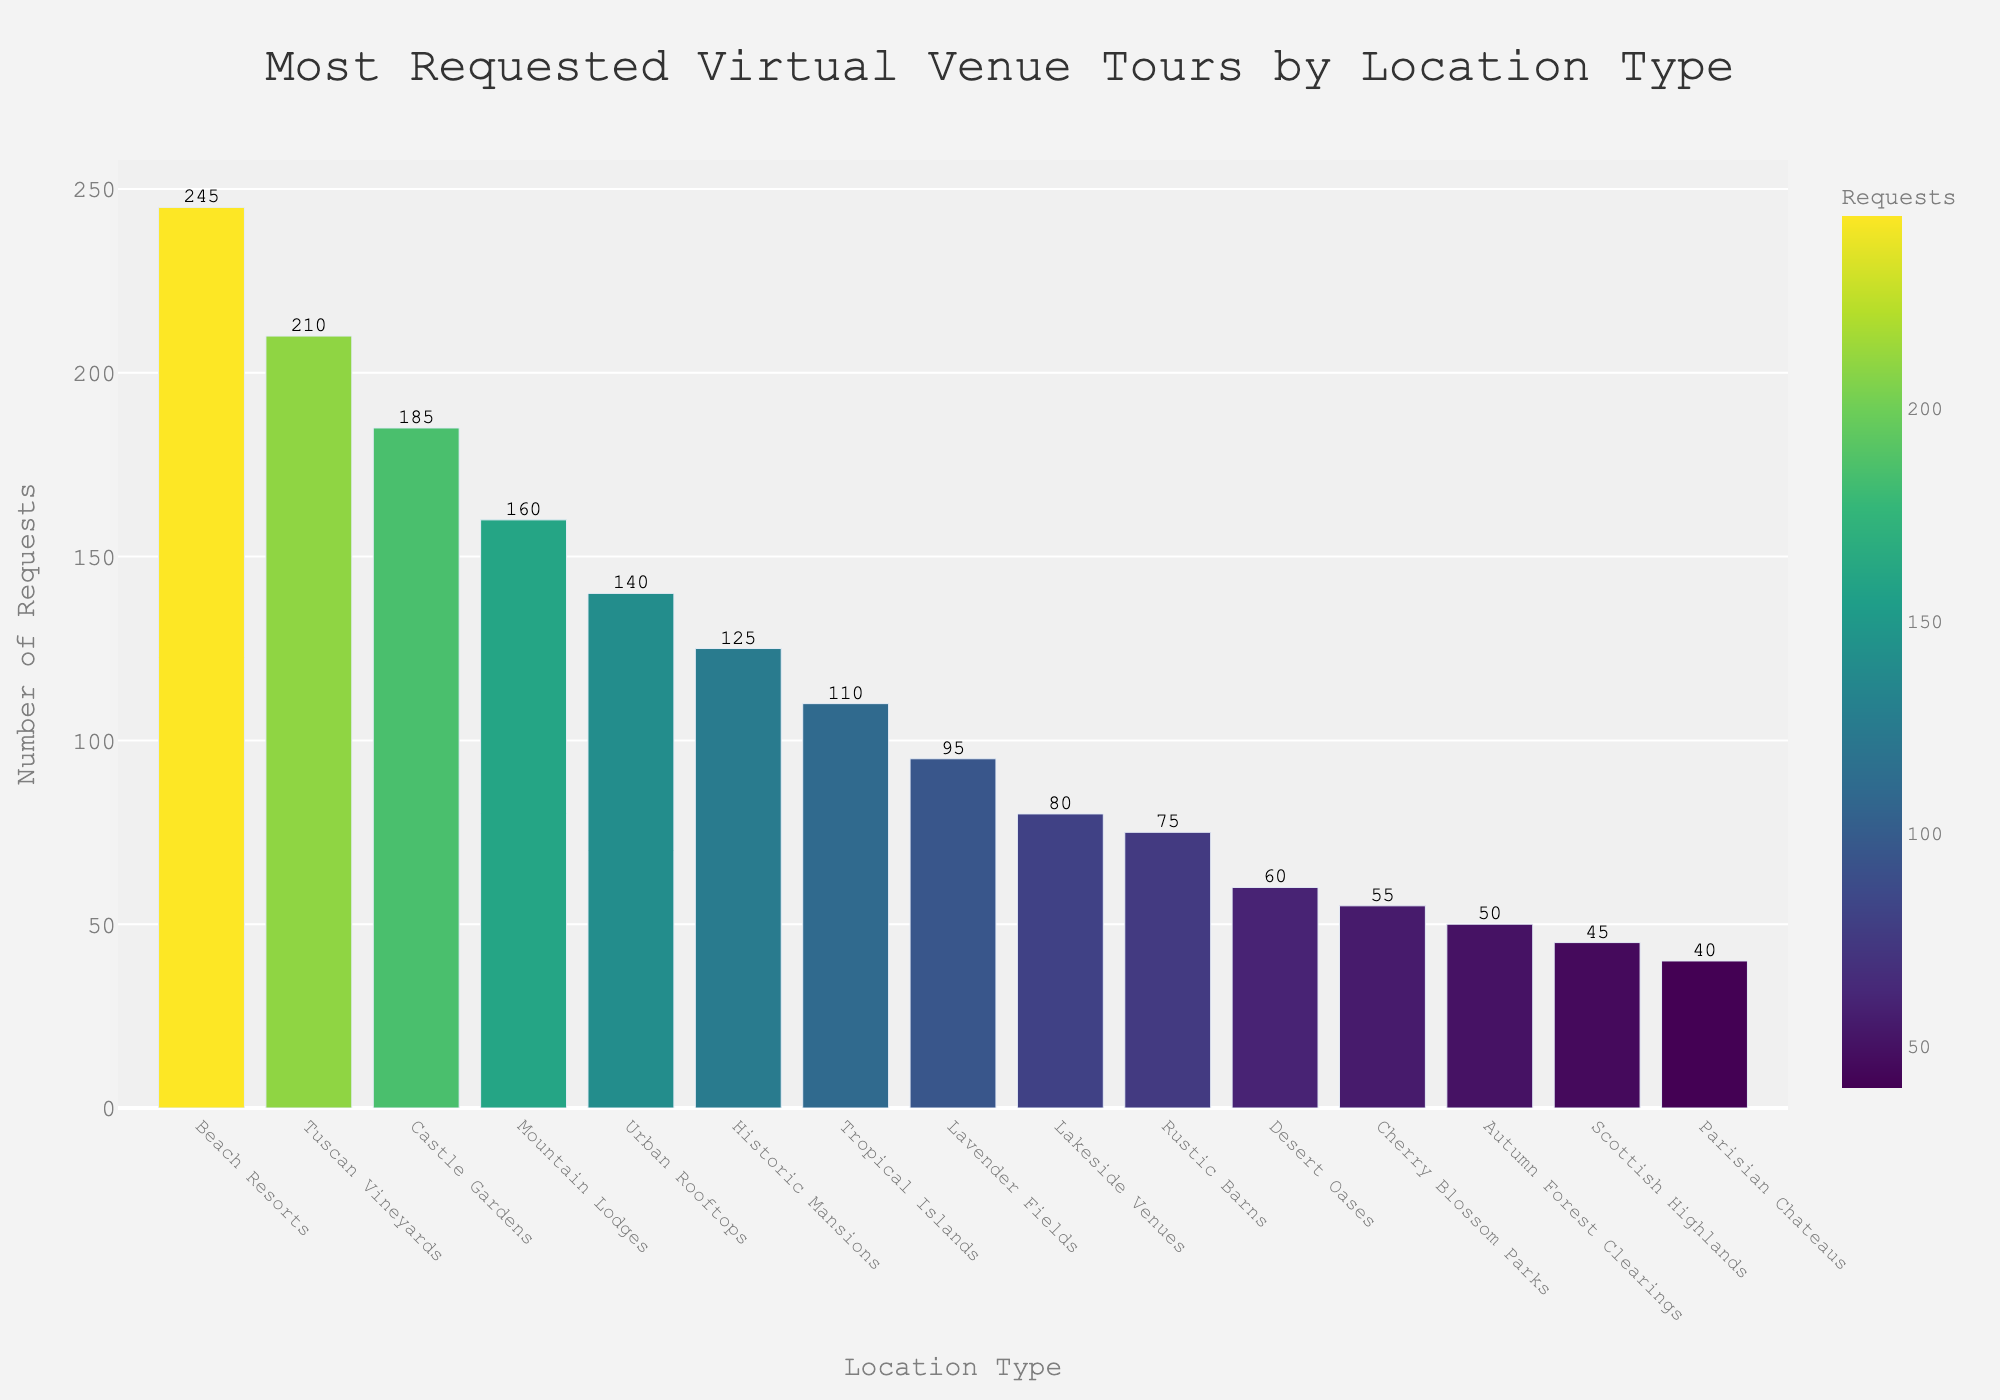Which location type received the highest number of virtual venue requests? The bar chart shows that the "Beach Resorts" bar is the tallest, indicating it received the highest number of requests.
Answer: Beach Resorts Which location type received the least number of virtual venue requests? The "Parisian Chateaus" bar is the shortest in the bar chart, indicating it received the least number of requests.
Answer: Parisian Chateaus How many more requests did Beach Resorts receive compared to Urban Rooftops? Beach Resorts have 245 requests and Urban Rooftops have 140 requests. Subtracting the two gives 245 - 140 = 105.
Answer: 105 What is the total number of requests for the top three location types? The top three are Beach Resorts (245), Tuscan Vineyards (210), and Castle Gardens (185). Summing them up gives 245 + 210 + 185 = 640.
Answer: 640 Which has more requests: Historic Mansions or Tropical Islands? Historic Mansions have 125 requests while Tropical Islands have 110 requests. 125 is greater than 110.
Answer: Historic Mansions Arrange the location types with fewer than 100 requests in ascending order based on the number of requests. The location types with fewer than 100 requests are Parisian Chateaus (40), Scottish Highlands (45), Autumn Forest Clearings (50), Cherry Blossom Parks (55), Desert Oases (60), Rustic Barns (75), Lakeside Venues (80), and Lavender Fields (95). Sorting them in ascending order: Parisian Chateaus, Scottish Highlands, Autumn Forest Clearings, Cherry Blossom Parks, Desert Oases, Rustic Barns, Lakeside Venues, Lavender Fields.
Answer: Parisian Chateaus, Scottish Highlands, Autumn Forest Clearings, Cherry Blossom Parks, Desert Oases, Rustic Barns, Lakeside Venues, Lavender Fields What is the average number of requests for all location types? There are 15 location types with request numbers: 245, 210, 185, 160, 140, 125, 110, 95, 80, 75, 60, 55, 50, 45, 40. The sum of these values is 1675. Dividing by the number of location types (15), we get 1675 / 15 ≈ 111.7.
Answer: 111.7 